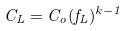<formula> <loc_0><loc_0><loc_500><loc_500>C _ { L } = C _ { o } ( f _ { L } ) ^ { k - 1 }</formula> 